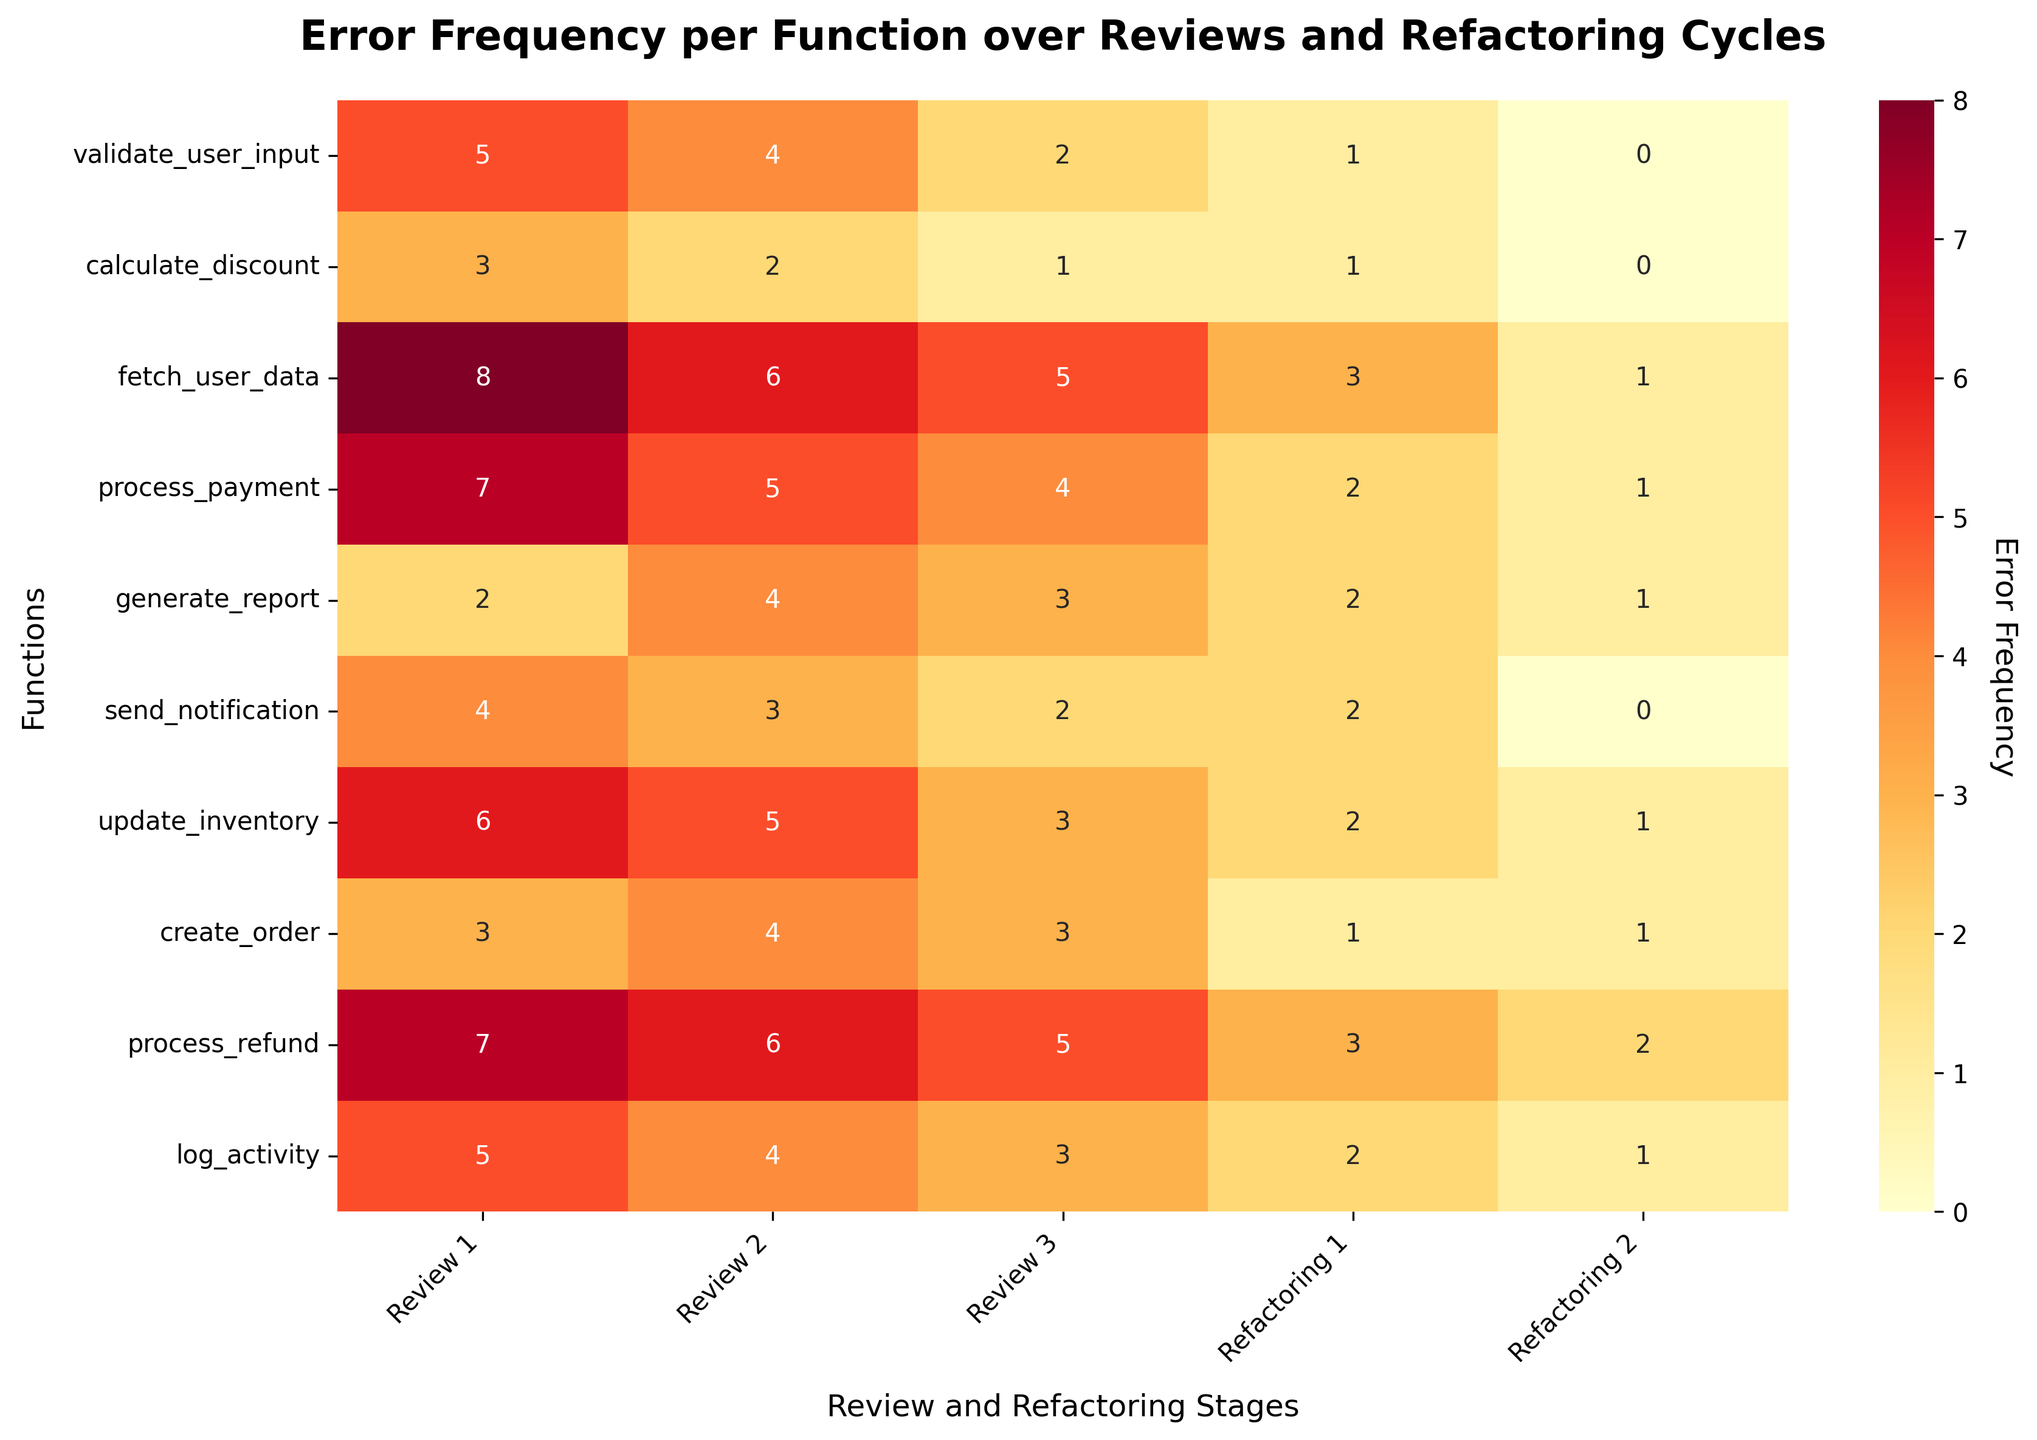what is the title of the figure? The title is located at the top of the figure in a bold font. It gives a description of what the figure represents. The title in this case is 'Error Frequency per Function over Reviews and Refactoring Cycles'.
Answer: Error Frequency per Function over Reviews and Refactoring Cycles How many functions were analyzed in the heatmap? Count the number of rows in the heatmap, each representing a different function. There are 10 functions in total as seen from the y-axis labels.
Answer: 10 Which function had the highest error frequency during "Review 1"? Look at the cells under "Review 1" and find the highest value. The function 'fetch_user_data' has 8 errors, which is the highest.
Answer: fetch_user_data What is the error frequency for the function 'process_payment' at 'Refactoring 1'? Locate the cell at the intersection of 'process_payment' (y-axis) and 'Refactoring 1' (x-axis). The cell indicates an error frequency of 2.
Answer: 2 Which review or refactoring stage shows the most overall improvement in error frequency compared to the previous stage? Calculate the total errors for each stage and compare the drops. The stage 'Refactoring 1' has a total error reduction of 20 compared to 'Review 3', which is the most significant improvement.
Answer: Refactoring 1 What is the average error frequency for the function 'create_order' over all stages? Add the error frequencies for 'create_order' across all stages and divide by the number of stages (5). The sum is 3 + 4 + 3 + 1 + 1 = 12, and the average is 12/5 = 2.4.
Answer: 2.4 Which function had the greatest error reduction from 'Review 1' to 'Refactoring 2'? Determine the difference between errors in 'Review 1' and 'Refactoring 2' for each function and identify the greatest value. 'fetch_user_data' has an error reduction of 8 - 1 = 7, the greatest among all functions.
Answer: fetch_user_data For 'Review 2', what is the sum of errors across all functions? Add the error frequencies for all functions in 'Review 2'. The sum is 4 + 2 + 6 + 5 + 4 + 3 + 5 + 4 + 6 + 4 = 43.
Answer: 43 How does the error frequency trend for 'log_activity' change from 'Review 1' to 'Refactoring 2'? Observe the values for 'log_activity' across the stages: 5 (Review 1), 4 (Review 2), 3 (Review 3), 2 (Refactoring 1), 1 (Refactoring 2), showing a steady decreasing trend.
Answer: Decreasing Which review stage had an equal number of errors for both 'calculate_discount' and 'send_notification'? Compare the error frequencies for 'calculate_discount' and 'send_notification' across all stages to find where they are equal. In 'Review 2', both functions have an error frequency of 3.
Answer: Review 2 